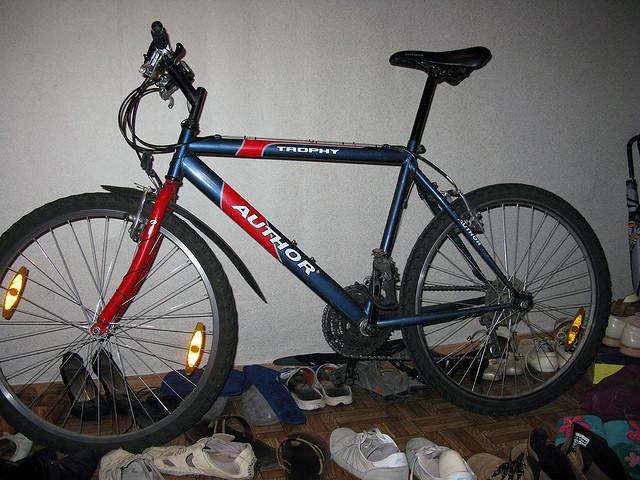Name a sponsor for this rider?
Quick response, please. Author. Which tire has more reflectors?
Be succinct. Front. What is lying on the ground behind the bike?
Short answer required. Shoes. How many spokes does this bicycle have?
Answer briefly. 100. Is there a lot of shoes in this picture?
Quick response, please. Yes. What are the metal rods inside the wheels called?
Write a very short answer. Spokes. What color is the bike?
Write a very short answer. Blue and red. 